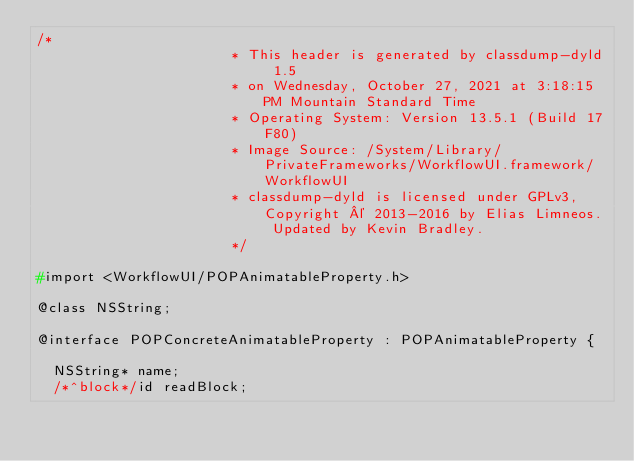Convert code to text. <code><loc_0><loc_0><loc_500><loc_500><_C_>/*
                       * This header is generated by classdump-dyld 1.5
                       * on Wednesday, October 27, 2021 at 3:18:15 PM Mountain Standard Time
                       * Operating System: Version 13.5.1 (Build 17F80)
                       * Image Source: /System/Library/PrivateFrameworks/WorkflowUI.framework/WorkflowUI
                       * classdump-dyld is licensed under GPLv3, Copyright © 2013-2016 by Elias Limneos. Updated by Kevin Bradley.
                       */

#import <WorkflowUI/POPAnimatableProperty.h>

@class NSString;

@interface POPConcreteAnimatableProperty : POPAnimatableProperty {

	NSString* name;
	/*^block*/id readBlock;</code> 